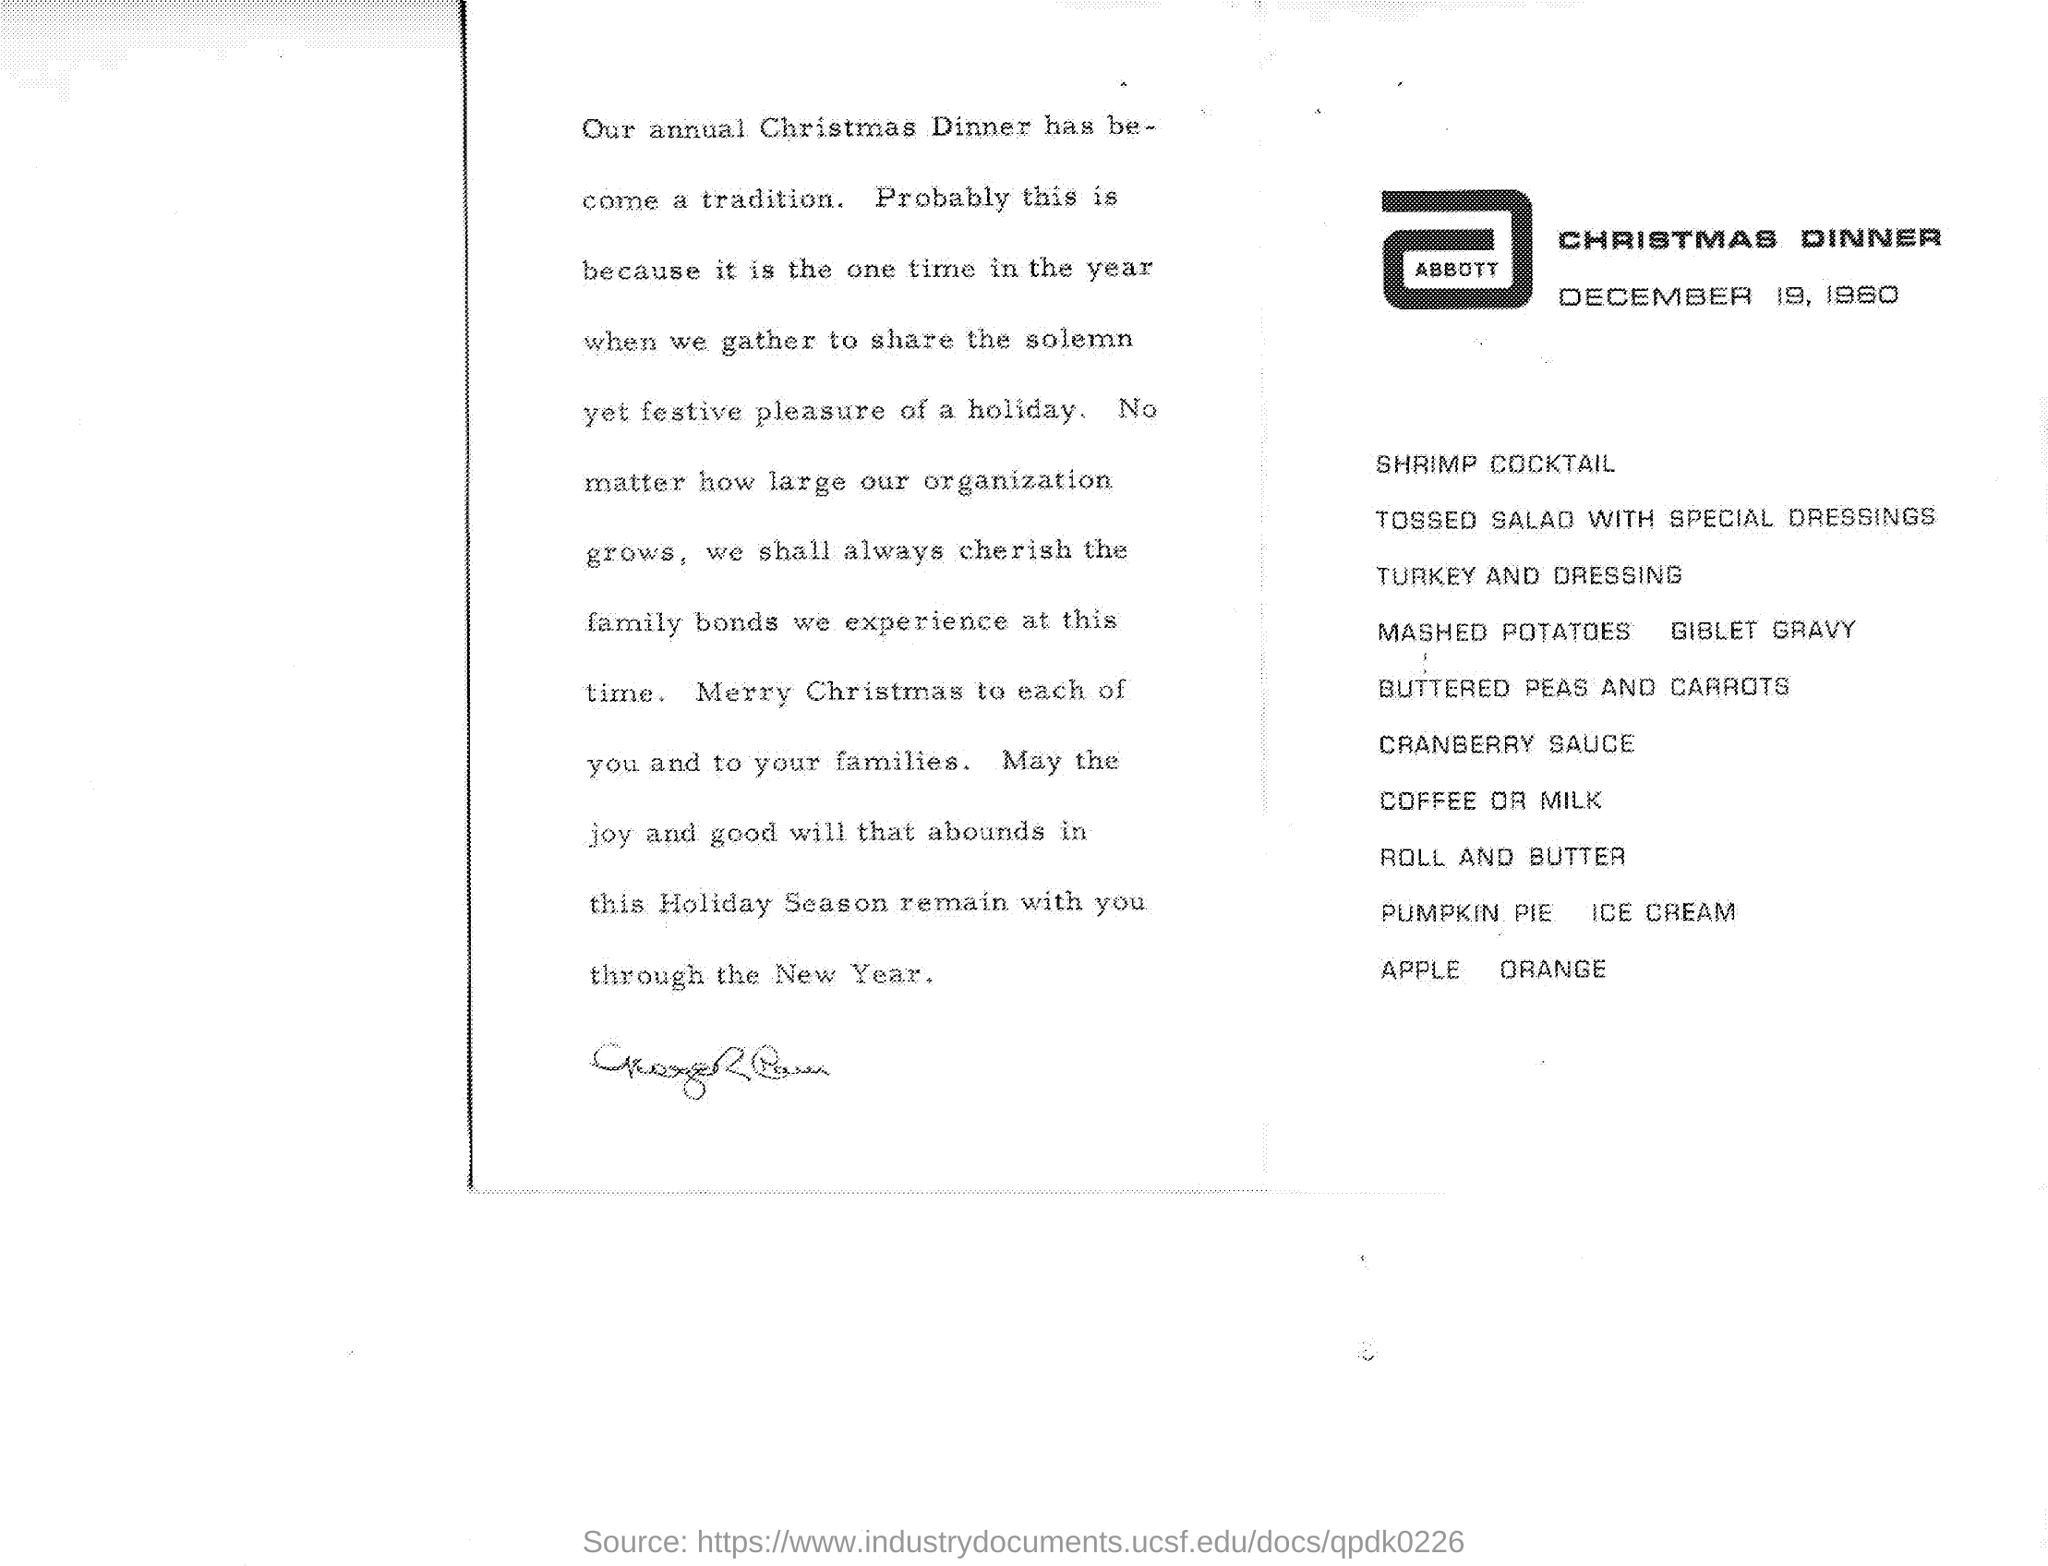When is the Christmas Dinner?
Provide a short and direct response. December 19, 1960. 